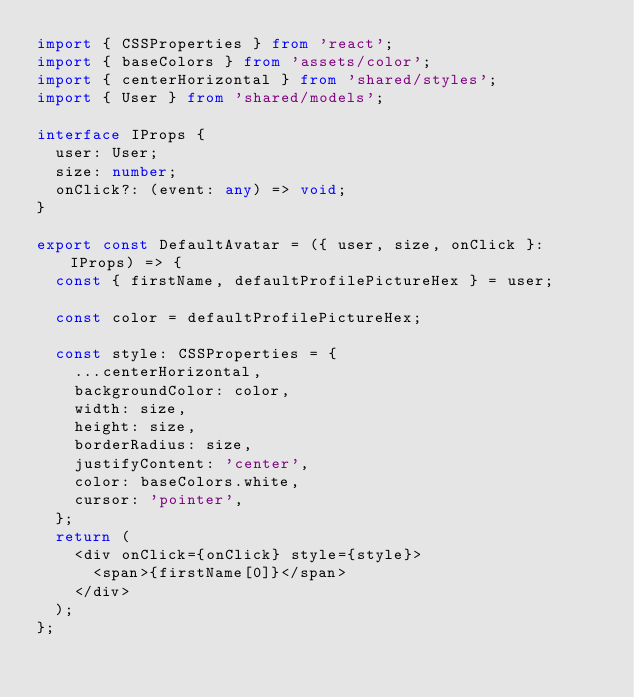Convert code to text. <code><loc_0><loc_0><loc_500><loc_500><_TypeScript_>import { CSSProperties } from 'react';
import { baseColors } from 'assets/color';
import { centerHorizontal } from 'shared/styles';
import { User } from 'shared/models';

interface IProps {
  user: User;
  size: number;
  onClick?: (event: any) => void;
}

export const DefaultAvatar = ({ user, size, onClick }: IProps) => {
  const { firstName, defaultProfilePictureHex } = user;

  const color = defaultProfilePictureHex;

  const style: CSSProperties = {
    ...centerHorizontal,
    backgroundColor: color,
    width: size,
    height: size,
    borderRadius: size,
    justifyContent: 'center',
    color: baseColors.white,
    cursor: 'pointer',
  };
  return (
    <div onClick={onClick} style={style}>
      <span>{firstName[0]}</span>
    </div>
  );
};
</code> 